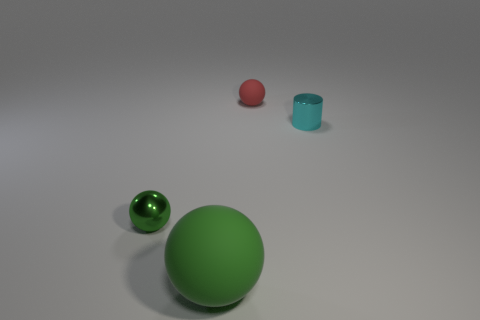Add 4 tiny green metal things. How many objects exist? 8 Subtract all green balls. How many balls are left? 1 Subtract 1 spheres. How many spheres are left? 2 Subtract all cylinders. How many objects are left? 3 Subtract all small green metallic balls. Subtract all rubber balls. How many objects are left? 1 Add 2 green things. How many green things are left? 4 Add 4 large cyan shiny blocks. How many large cyan shiny blocks exist? 4 Subtract 1 red balls. How many objects are left? 3 